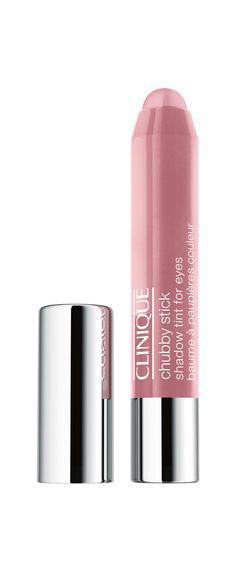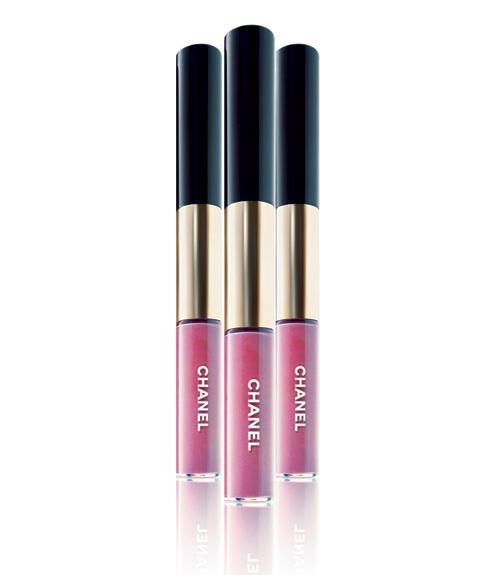The first image is the image on the left, the second image is the image on the right. Assess this claim about the two images: "An image includes one exposed lipstick wand and no tube lipsticks.". Correct or not? Answer yes or no. No. The first image is the image on the left, the second image is the image on the right. Examine the images to the left and right. Is the description "One of the images shows a foam-tipped lip applicator." accurate? Answer yes or no. No. 